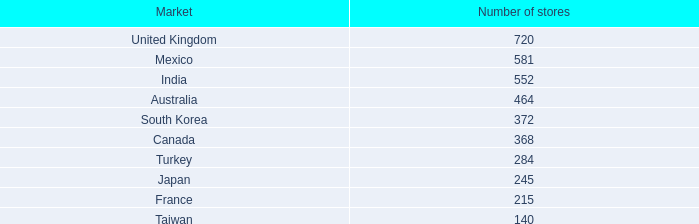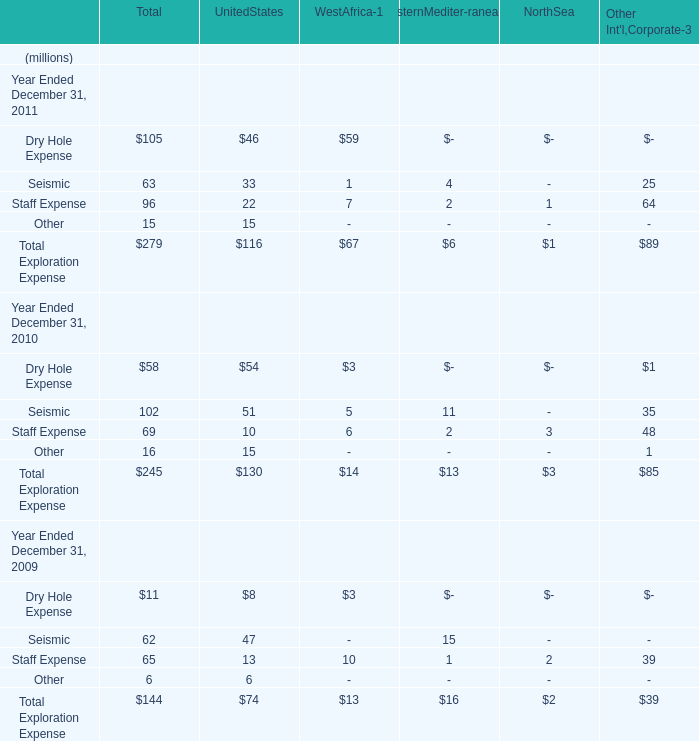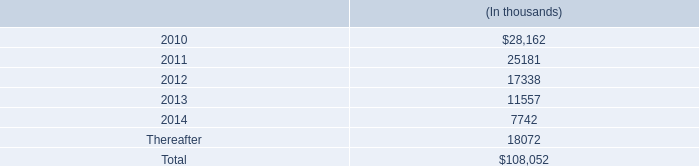as of december 31 , 2009 , what percentage of the $ 150.0 million authorization remained available for repurchase of the company 2019s common stock? 
Computations: (65.0 / 150.0)
Answer: 0.43333. 